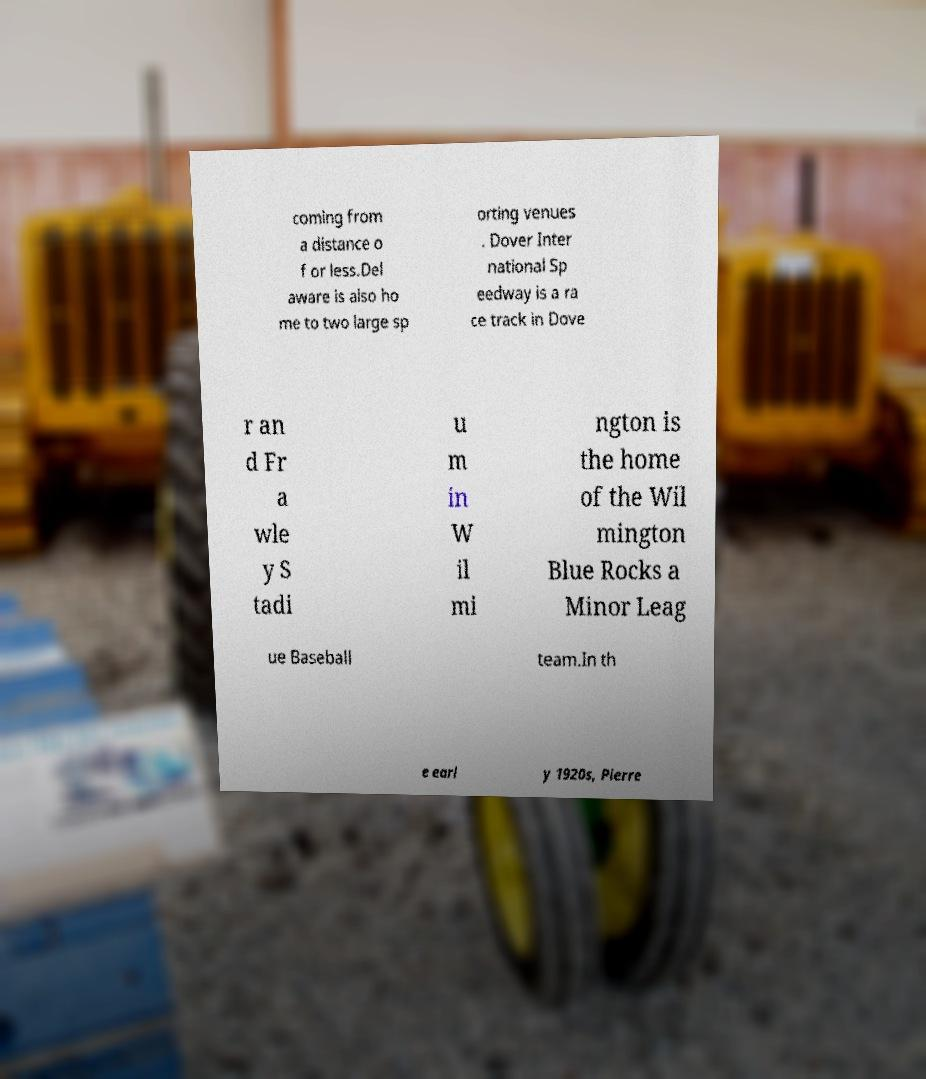Could you extract and type out the text from this image? coming from a distance o f or less.Del aware is also ho me to two large sp orting venues . Dover Inter national Sp eedway is a ra ce track in Dove r an d Fr a wle y S tadi u m in W il mi ngton is the home of the Wil mington Blue Rocks a Minor Leag ue Baseball team.In th e earl y 1920s, Pierre 